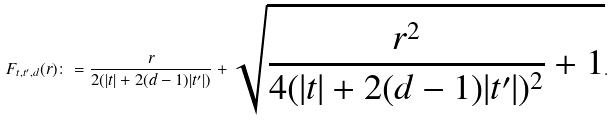<formula> <loc_0><loc_0><loc_500><loc_500>F _ { t , t ^ { \prime } , d } ( r ) \colon = \frac { r } { 2 ( | t | + 2 ( d - 1 ) | t ^ { \prime } | ) } + \sqrt { \frac { r ^ { 2 } } { 4 ( | t | + 2 ( d - 1 ) | t ^ { \prime } | ) ^ { 2 } } + 1 } .</formula> 